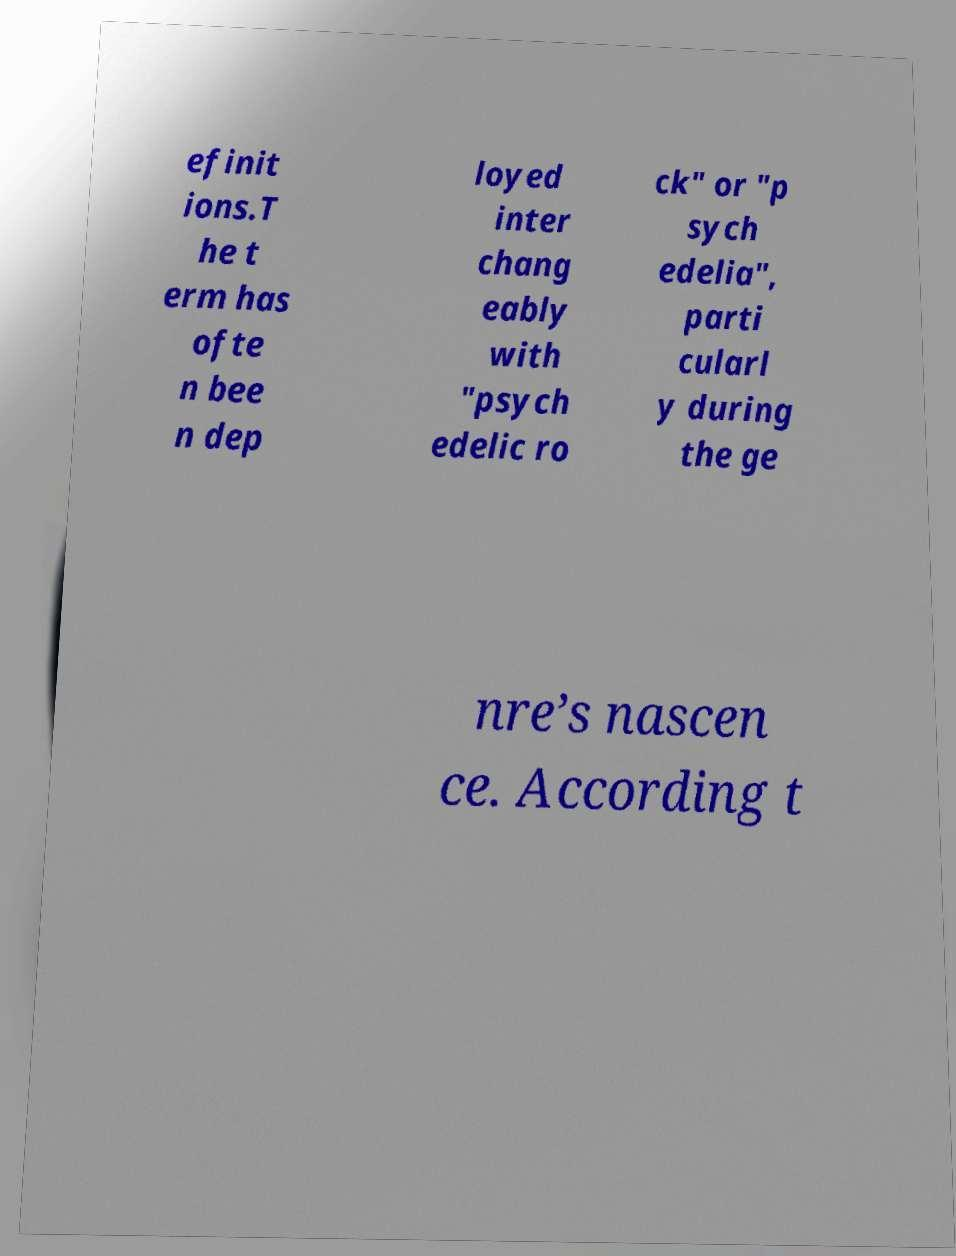Please read and relay the text visible in this image. What does it say? efinit ions.T he t erm has ofte n bee n dep loyed inter chang eably with "psych edelic ro ck" or "p sych edelia", parti cularl y during the ge nre’s nascen ce. According t 